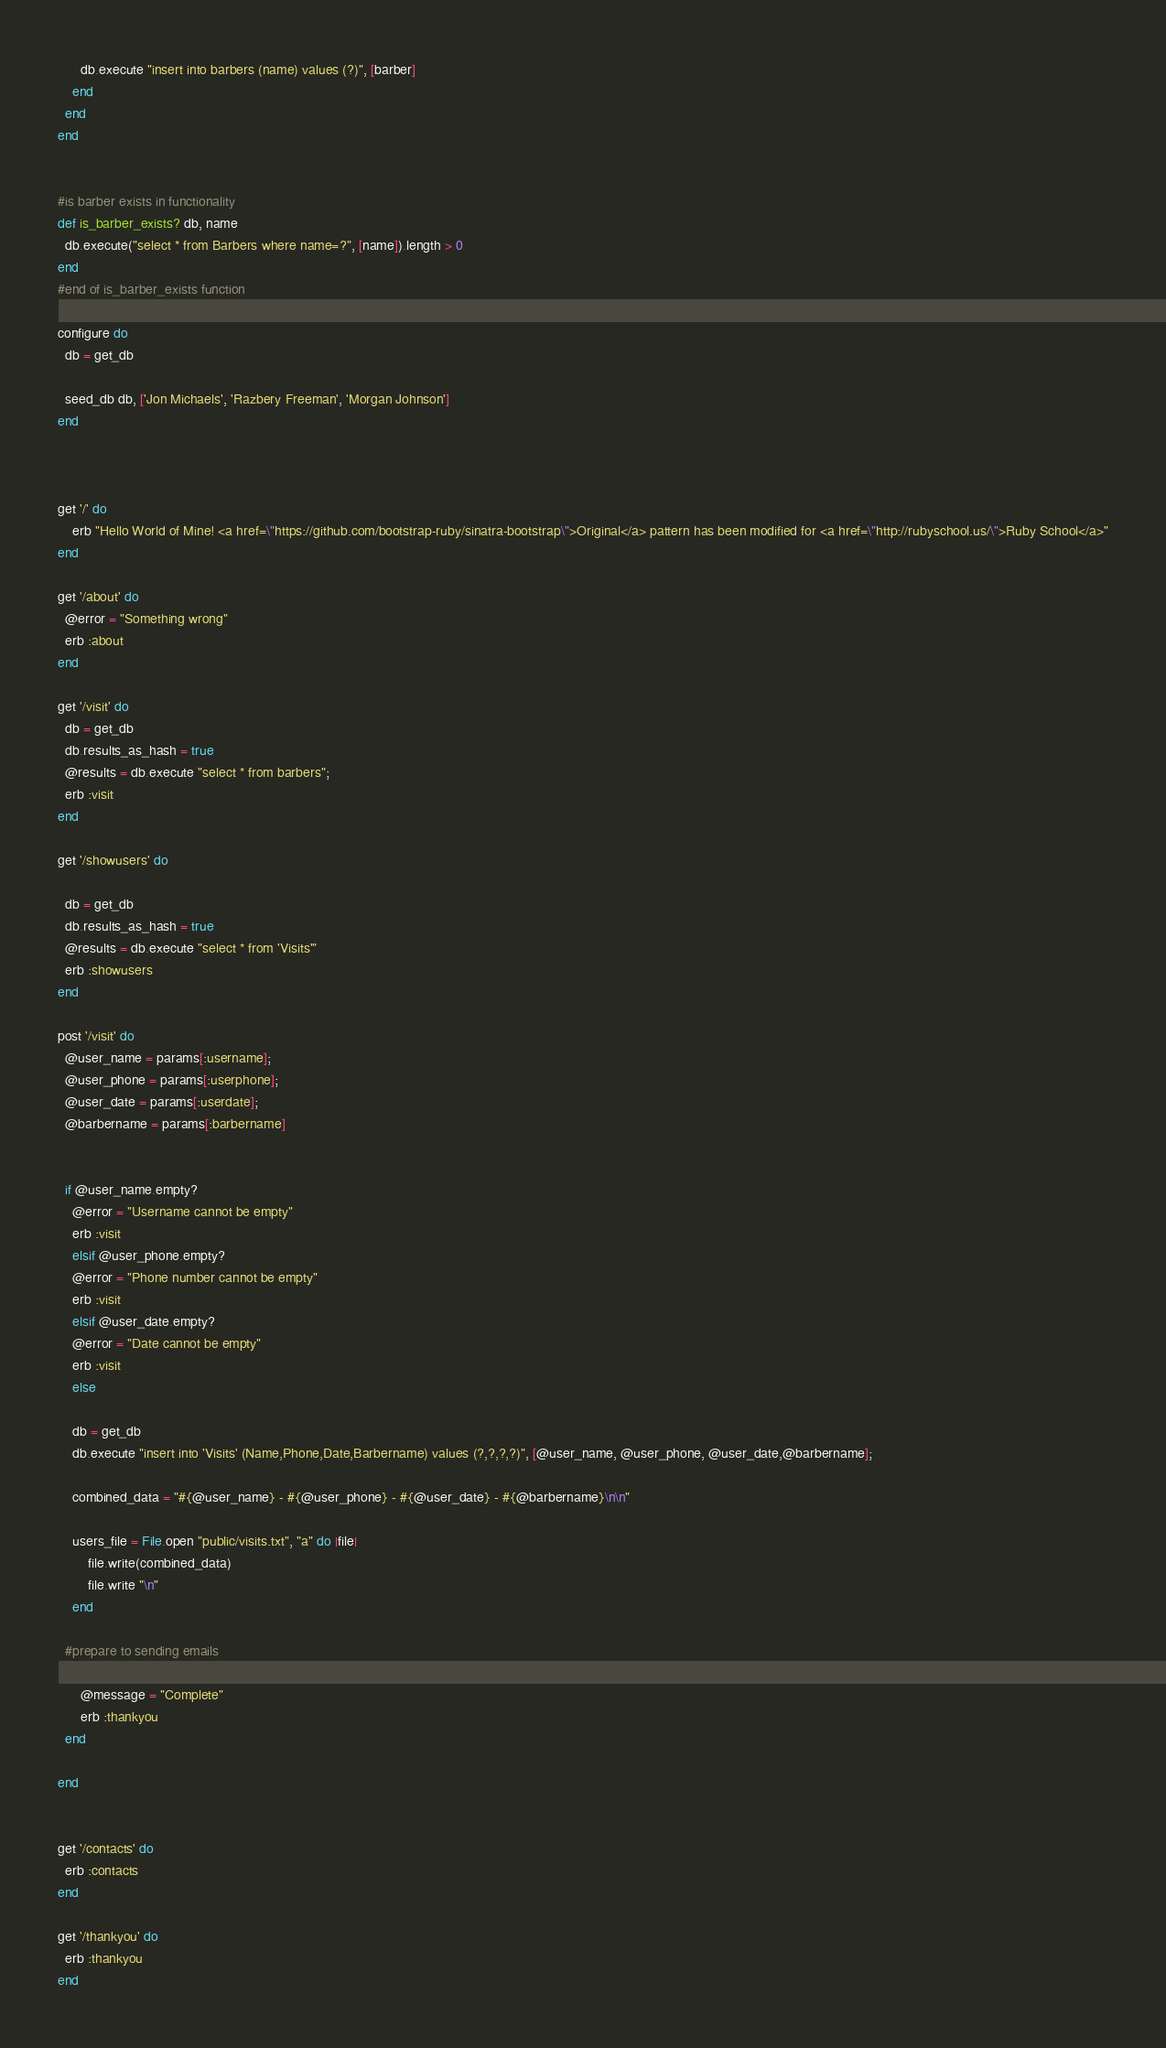Convert code to text. <code><loc_0><loc_0><loc_500><loc_500><_Ruby_>      db.execute "insert into barbers (name) values (?)", [barber]
    end
  end
end


#is barber exists in functionality
def is_barber_exists? db, name
  db.execute("select * from Barbers where name=?", [name]).length > 0
end
#end of is_barber_exists function

configure do
  db = get_db

  seed_db db, ['Jon Michaels', 'Razbery Freeman', 'Morgan Johnson']
end



get '/' do
	erb "Hello World of Mine! <a href=\"https://github.com/bootstrap-ruby/sinatra-bootstrap\">Original</a> pattern has been modified for <a href=\"http://rubyschool.us/\">Ruby School</a>"
end

get '/about' do
  @error = "Something wrong"
  erb :about
end

get '/visit' do
  db = get_db
  db.results_as_hash = true
  @results = db.execute "select * from barbers";
  erb :visit
end

get '/showusers' do

  db = get_db
  db.results_as_hash = true
  @results = db.execute "select * from 'Visits'"
  erb :showusers
end

post '/visit' do
  @user_name = params[:username];
  @user_phone = params[:userphone];
  @user_date = params[:userdate];
  @barbername = params[:barbername]


  if @user_name.empty?
    @error = "Username cannot be empty"
    erb :visit
    elsif @user_phone.empty?
    @error = "Phone number cannot be empty"
    erb :visit
    elsif @user_date.empty?
    @error = "Date cannot be empty"
    erb :visit
    else

    db = get_db
    db.execute "insert into 'Visits' (Name,Phone,Date,Barbername) values (?,?,?,?)", [@user_name, @user_phone, @user_date,@barbername];

    combined_data = "#{@user_name} - #{@user_phone} - #{@user_date} - #{@barbername}\n\n"

    users_file = File.open "public/visits.txt", "a" do |file|
        file.write(combined_data)
        file.write "\n"
    end

  #prepare to sending emails

      @message = "Complete"
      erb :thankyou
  end

end


get '/contacts' do
  erb :contacts
end

get '/thankyou' do
  erb :thankyou
end

</code> 